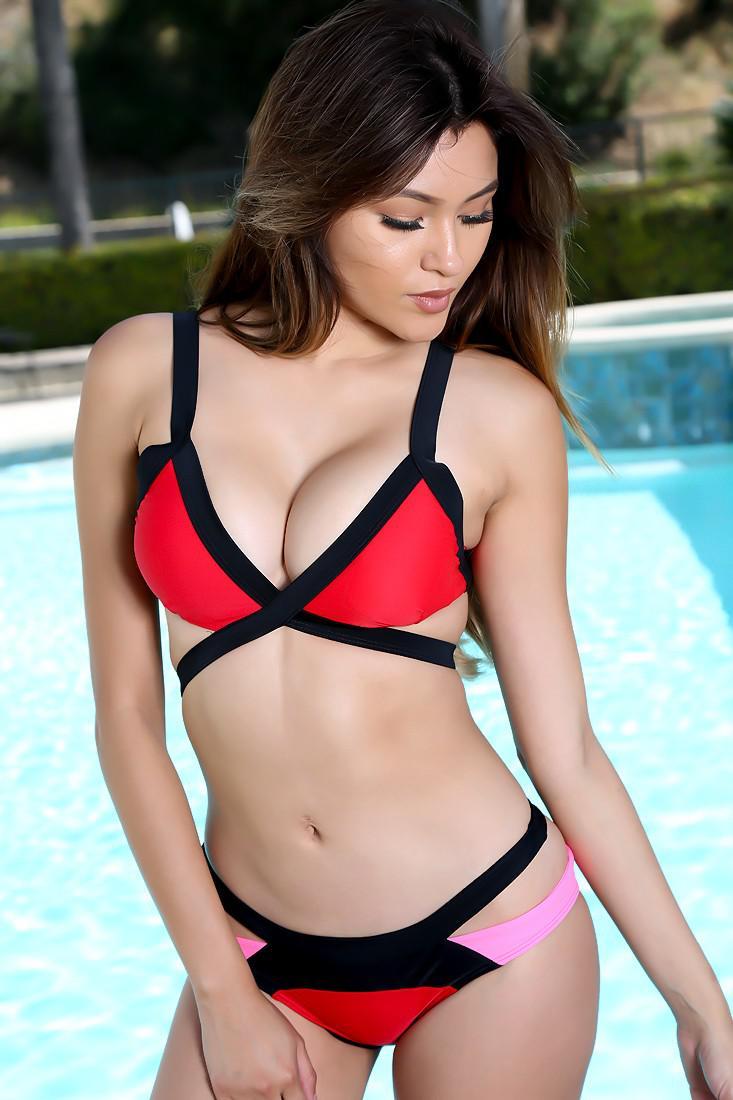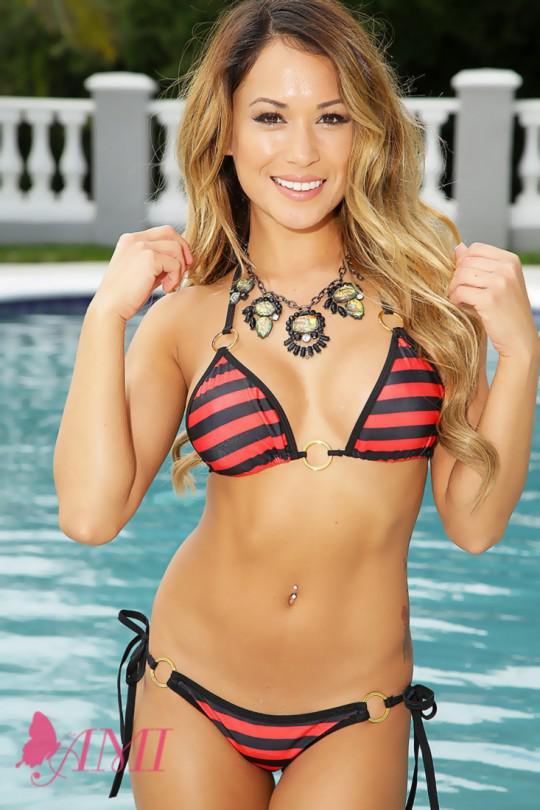The first image is the image on the left, the second image is the image on the right. Considering the images on both sides, is "One model poses in a bikini with horizontal stripes on the top and bottom." valid? Answer yes or no. Yes. 